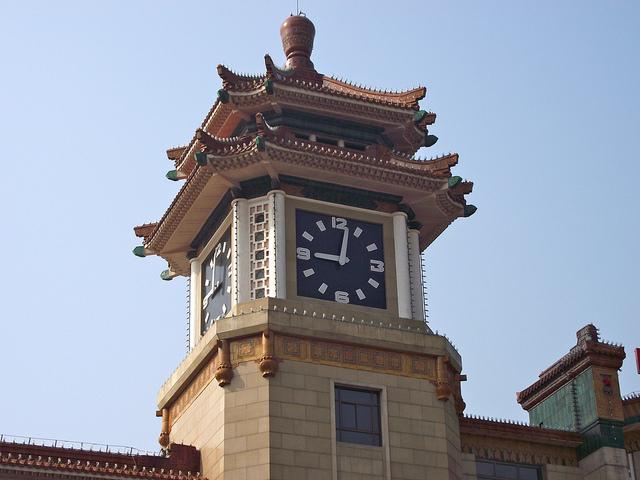How many clock are shown?
Give a very brief answer. 2. What object is at the very top of the structure?
Concise answer only. Clock. What time is displayed on the clock?
Be succinct. 9:01. How many numbers are on the clock?
Short answer required. 4. What time is it according to clock?
Give a very brief answer. 9:02. 